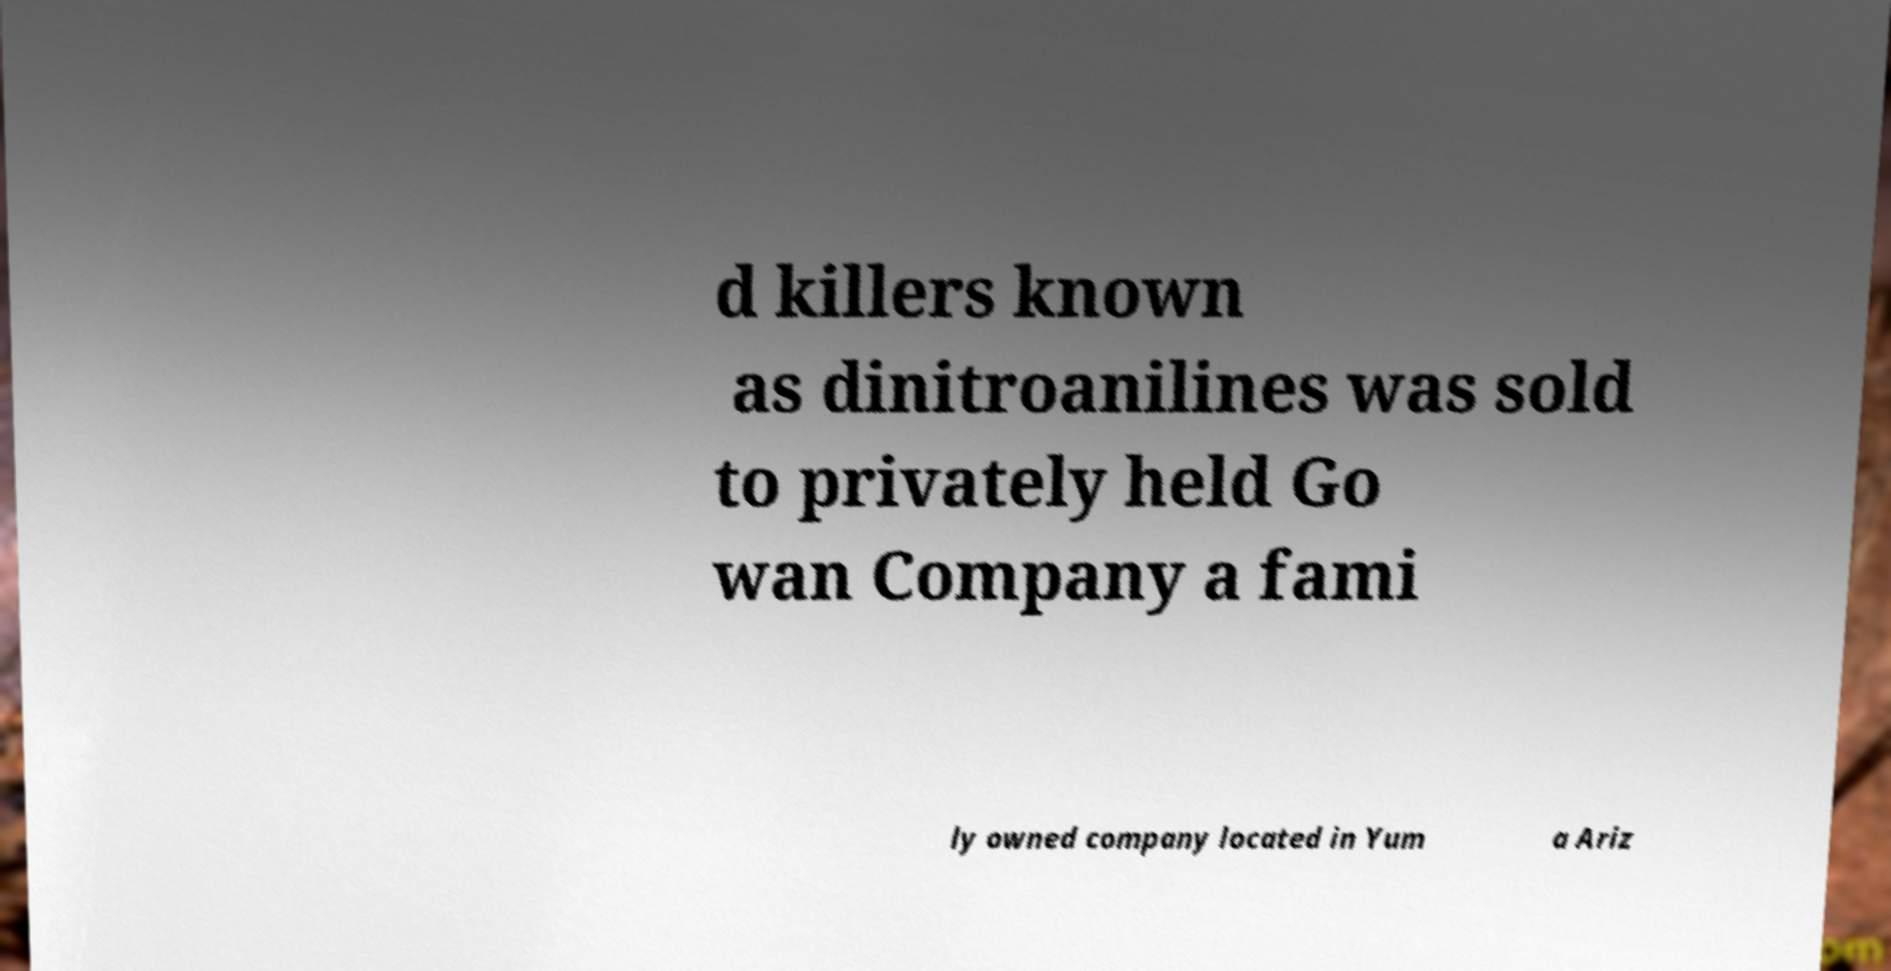Can you accurately transcribe the text from the provided image for me? d killers known as dinitroanilines was sold to privately held Go wan Company a fami ly owned company located in Yum a Ariz 